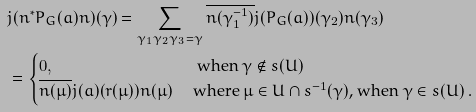<formula> <loc_0><loc_0><loc_500><loc_500>& j ( n ^ { * } P _ { G } ( a ) n ) ( \gamma ) = \sum _ { \gamma _ { 1 } \gamma _ { 2 } \gamma _ { 3 } = \gamma } \overline { n ( \gamma _ { 1 } ^ { - 1 } ) } j ( P _ { G } ( a ) ) ( \gamma _ { 2 } ) n ( \gamma _ { 3 } ) \\ & = \begin{cases} 0 , & \ \text {when} \ \gamma \notin s ( U ) \\ \overline { n ( \mu ) } j ( a ) ( r ( \mu ) ) n ( \mu ) \ & \text {where $\mu\in U \cap   s^{-1}(\gamma)$, when $\gamma \in s(U)$ .} \end{cases}</formula> 